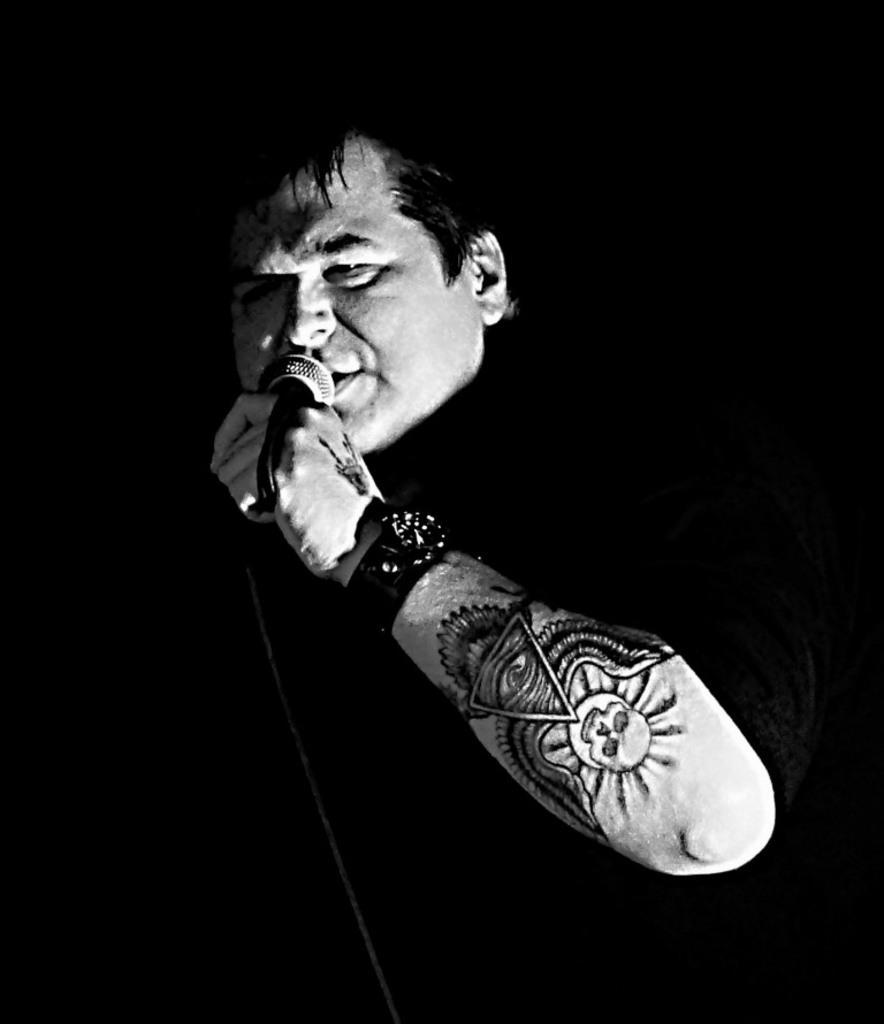Please provide a concise description of this image. In this image in the foreground there is one person holding the mike and there is a tattoo on his right hand. 